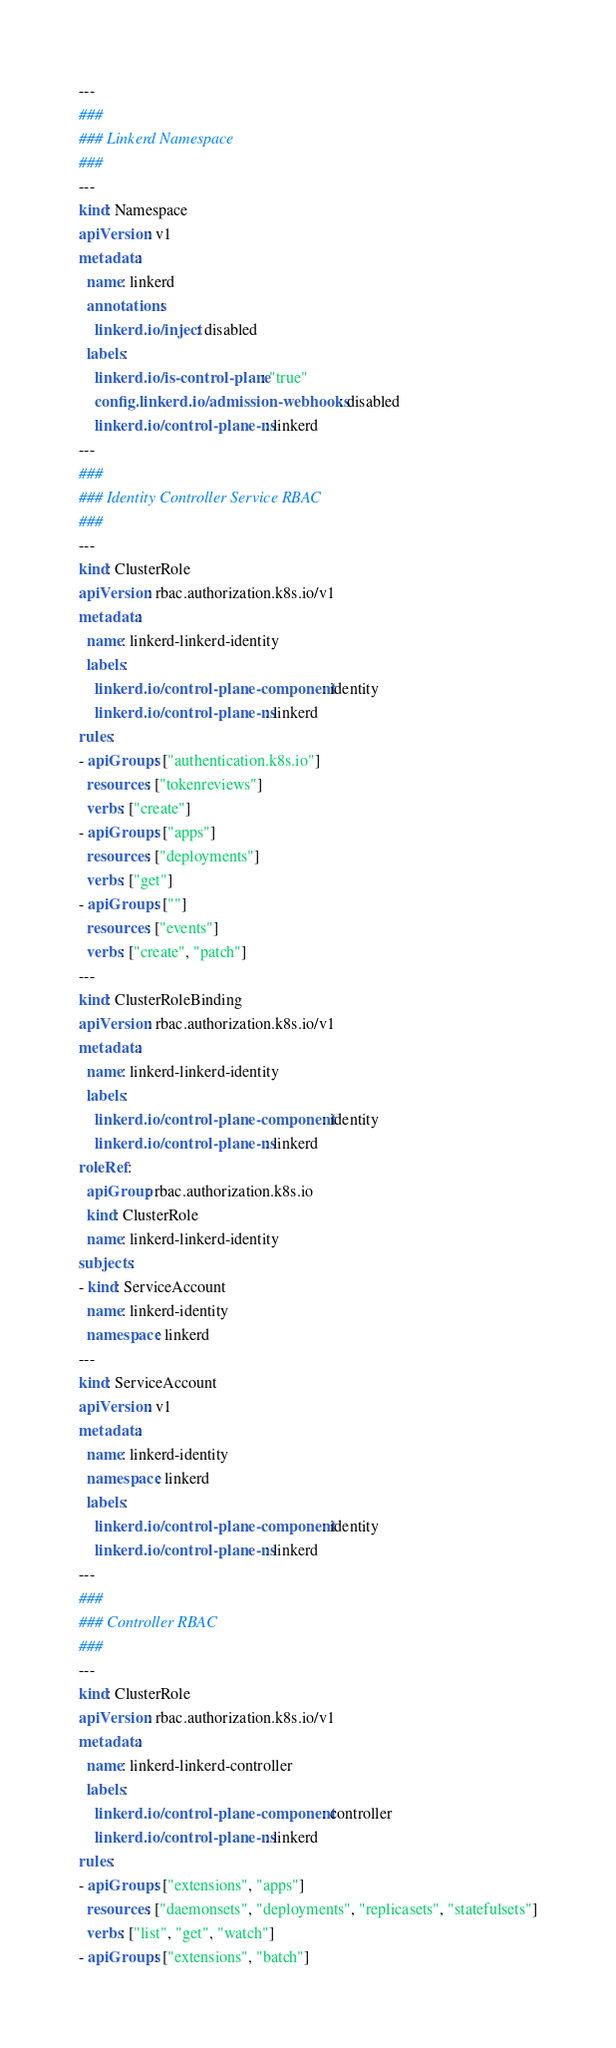Convert code to text. <code><loc_0><loc_0><loc_500><loc_500><_YAML_>---
###
### Linkerd Namespace
###
---
kind: Namespace
apiVersion: v1
metadata:
  name: linkerd
  annotations:
    linkerd.io/inject: disabled
  labels:
    linkerd.io/is-control-plane: "true"
    config.linkerd.io/admission-webhooks: disabled
    linkerd.io/control-plane-ns: linkerd
---
###
### Identity Controller Service RBAC
###
---
kind: ClusterRole
apiVersion: rbac.authorization.k8s.io/v1
metadata:
  name: linkerd-linkerd-identity
  labels:
    linkerd.io/control-plane-component: identity
    linkerd.io/control-plane-ns: linkerd
rules:
- apiGroups: ["authentication.k8s.io"]
  resources: ["tokenreviews"]
  verbs: ["create"]
- apiGroups: ["apps"]
  resources: ["deployments"]
  verbs: ["get"]
- apiGroups: [""]
  resources: ["events"]
  verbs: ["create", "patch"]
---
kind: ClusterRoleBinding
apiVersion: rbac.authorization.k8s.io/v1
metadata:
  name: linkerd-linkerd-identity
  labels:
    linkerd.io/control-plane-component: identity
    linkerd.io/control-plane-ns: linkerd
roleRef:
  apiGroup: rbac.authorization.k8s.io
  kind: ClusterRole
  name: linkerd-linkerd-identity
subjects:
- kind: ServiceAccount
  name: linkerd-identity
  namespace: linkerd
---
kind: ServiceAccount
apiVersion: v1
metadata:
  name: linkerd-identity
  namespace: linkerd
  labels:
    linkerd.io/control-plane-component: identity
    linkerd.io/control-plane-ns: linkerd
---
###
### Controller RBAC
###
---
kind: ClusterRole
apiVersion: rbac.authorization.k8s.io/v1
metadata:
  name: linkerd-linkerd-controller
  labels:
    linkerd.io/control-plane-component: controller
    linkerd.io/control-plane-ns: linkerd
rules:
- apiGroups: ["extensions", "apps"]
  resources: ["daemonsets", "deployments", "replicasets", "statefulsets"]
  verbs: ["list", "get", "watch"]
- apiGroups: ["extensions", "batch"]</code> 